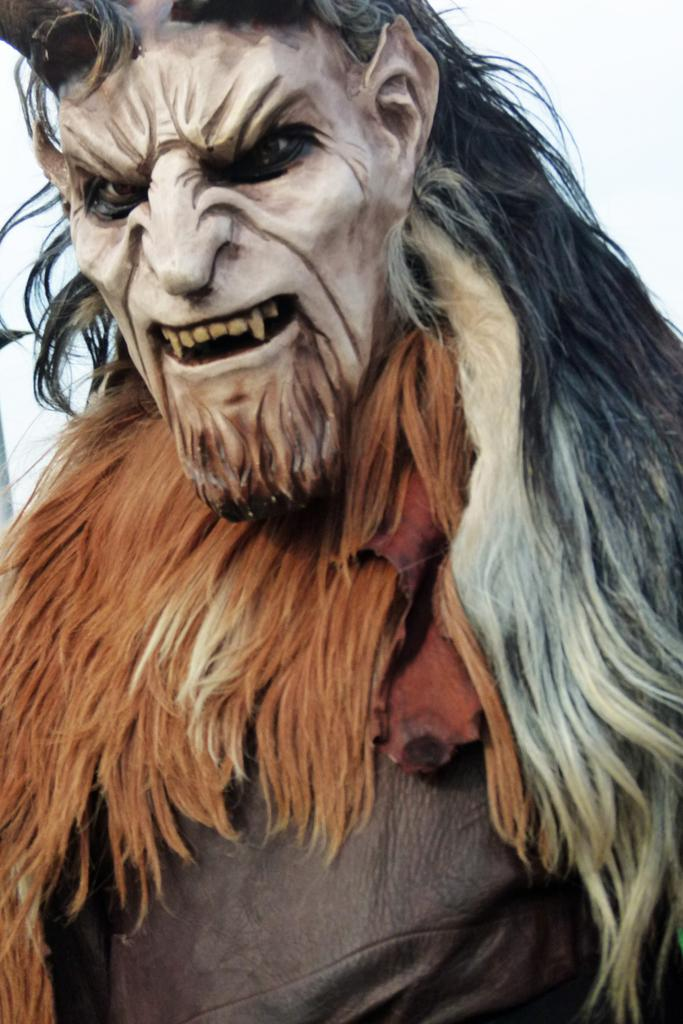Where was the image taken? The image is taken outdoors. What can be seen at the top of the image? The sky is visible at the top of the image. Is there a person in the image? Yes, there is a person in the image. What is the person wearing on their face? The person is wearing a face mask. How does the face mask look? The face mask has a weird appearance. What type of chalk is being used by the frogs in the image? There are no frogs or chalk present in the image. Is there a bathtub visible in the image? No, there is no bathtub visible in the image. 